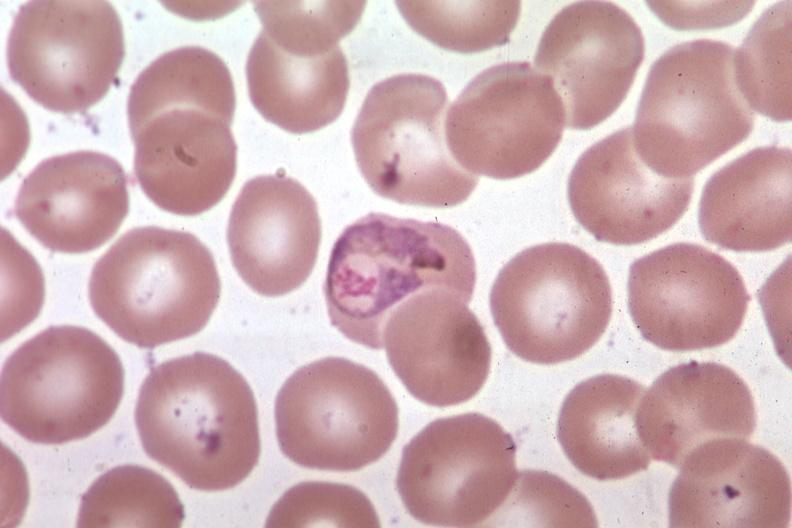what is present?
Answer the question using a single word or phrase. Hematologic 